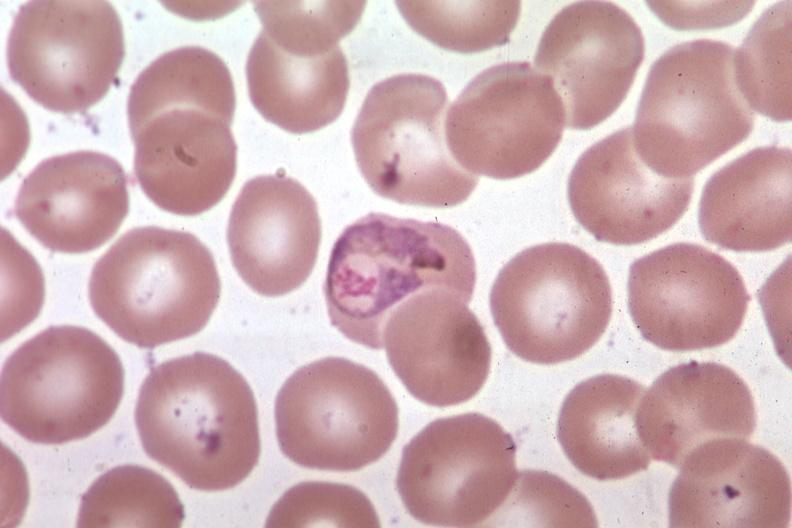what is present?
Answer the question using a single word or phrase. Hematologic 